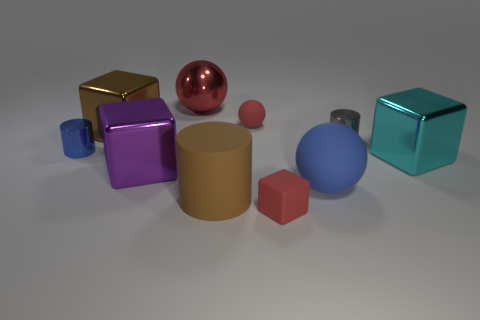Subtract all balls. How many objects are left? 7 Add 7 small red spheres. How many small red spheres exist? 8 Subtract 1 red blocks. How many objects are left? 9 Subtract all big cyan blocks. Subtract all metallic things. How many objects are left? 3 Add 2 brown metal cubes. How many brown metal cubes are left? 3 